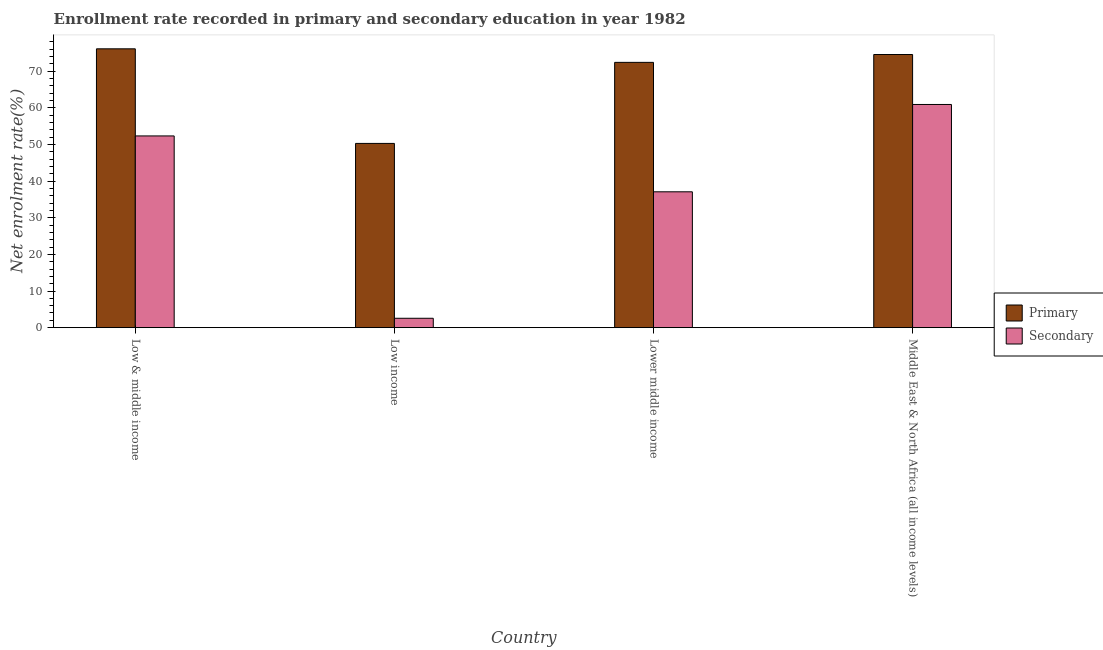How many different coloured bars are there?
Ensure brevity in your answer.  2. How many groups of bars are there?
Provide a short and direct response. 4. Are the number of bars per tick equal to the number of legend labels?
Offer a terse response. Yes. How many bars are there on the 3rd tick from the right?
Make the answer very short. 2. In how many cases, is the number of bars for a given country not equal to the number of legend labels?
Ensure brevity in your answer.  0. What is the enrollment rate in secondary education in Middle East & North Africa (all income levels)?
Make the answer very short. 60.88. Across all countries, what is the maximum enrollment rate in secondary education?
Give a very brief answer. 60.88. Across all countries, what is the minimum enrollment rate in secondary education?
Provide a succinct answer. 2.56. In which country was the enrollment rate in secondary education minimum?
Make the answer very short. Low income. What is the total enrollment rate in secondary education in the graph?
Your answer should be compact. 152.8. What is the difference between the enrollment rate in primary education in Low income and that in Lower middle income?
Keep it short and to the point. -22.11. What is the difference between the enrollment rate in secondary education in Low income and the enrollment rate in primary education in Middle East & North Africa (all income levels)?
Ensure brevity in your answer.  -71.95. What is the average enrollment rate in secondary education per country?
Give a very brief answer. 38.2. What is the difference between the enrollment rate in secondary education and enrollment rate in primary education in Low & middle income?
Keep it short and to the point. -23.76. In how many countries, is the enrollment rate in primary education greater than 2 %?
Give a very brief answer. 4. What is the ratio of the enrollment rate in primary education in Low & middle income to that in Low income?
Keep it short and to the point. 1.51. Is the enrollment rate in primary education in Low & middle income less than that in Middle East & North Africa (all income levels)?
Your answer should be compact. No. What is the difference between the highest and the second highest enrollment rate in secondary education?
Ensure brevity in your answer.  8.58. What is the difference between the highest and the lowest enrollment rate in primary education?
Your response must be concise. 25.8. What does the 1st bar from the left in Low income represents?
Make the answer very short. Primary. What does the 2nd bar from the right in Low income represents?
Ensure brevity in your answer.  Primary. How many bars are there?
Your answer should be compact. 8. Are the values on the major ticks of Y-axis written in scientific E-notation?
Give a very brief answer. No. How many legend labels are there?
Give a very brief answer. 2. What is the title of the graph?
Provide a succinct answer. Enrollment rate recorded in primary and secondary education in year 1982. Does "Borrowers" appear as one of the legend labels in the graph?
Make the answer very short. No. What is the label or title of the X-axis?
Ensure brevity in your answer.  Country. What is the label or title of the Y-axis?
Provide a short and direct response. Net enrolment rate(%). What is the Net enrolment rate(%) of Primary in Low & middle income?
Give a very brief answer. 76.06. What is the Net enrolment rate(%) of Secondary in Low & middle income?
Your answer should be compact. 52.3. What is the Net enrolment rate(%) in Primary in Low income?
Provide a short and direct response. 50.26. What is the Net enrolment rate(%) in Secondary in Low income?
Your response must be concise. 2.56. What is the Net enrolment rate(%) in Primary in Lower middle income?
Your answer should be very brief. 72.37. What is the Net enrolment rate(%) of Secondary in Lower middle income?
Offer a very short reply. 37.06. What is the Net enrolment rate(%) in Primary in Middle East & North Africa (all income levels)?
Keep it short and to the point. 74.51. What is the Net enrolment rate(%) in Secondary in Middle East & North Africa (all income levels)?
Offer a terse response. 60.88. Across all countries, what is the maximum Net enrolment rate(%) of Primary?
Your answer should be very brief. 76.06. Across all countries, what is the maximum Net enrolment rate(%) of Secondary?
Offer a very short reply. 60.88. Across all countries, what is the minimum Net enrolment rate(%) in Primary?
Offer a terse response. 50.26. Across all countries, what is the minimum Net enrolment rate(%) in Secondary?
Provide a short and direct response. 2.56. What is the total Net enrolment rate(%) in Primary in the graph?
Give a very brief answer. 273.2. What is the total Net enrolment rate(%) of Secondary in the graph?
Your response must be concise. 152.8. What is the difference between the Net enrolment rate(%) of Primary in Low & middle income and that in Low income?
Your answer should be very brief. 25.8. What is the difference between the Net enrolment rate(%) of Secondary in Low & middle income and that in Low income?
Offer a terse response. 49.74. What is the difference between the Net enrolment rate(%) in Primary in Low & middle income and that in Lower middle income?
Provide a succinct answer. 3.7. What is the difference between the Net enrolment rate(%) of Secondary in Low & middle income and that in Lower middle income?
Give a very brief answer. 15.24. What is the difference between the Net enrolment rate(%) of Primary in Low & middle income and that in Middle East & North Africa (all income levels)?
Keep it short and to the point. 1.55. What is the difference between the Net enrolment rate(%) in Secondary in Low & middle income and that in Middle East & North Africa (all income levels)?
Your answer should be compact. -8.58. What is the difference between the Net enrolment rate(%) of Primary in Low income and that in Lower middle income?
Provide a succinct answer. -22.11. What is the difference between the Net enrolment rate(%) in Secondary in Low income and that in Lower middle income?
Provide a succinct answer. -34.5. What is the difference between the Net enrolment rate(%) of Primary in Low income and that in Middle East & North Africa (all income levels)?
Offer a terse response. -24.25. What is the difference between the Net enrolment rate(%) of Secondary in Low income and that in Middle East & North Africa (all income levels)?
Your answer should be compact. -58.32. What is the difference between the Net enrolment rate(%) in Primary in Lower middle income and that in Middle East & North Africa (all income levels)?
Give a very brief answer. -2.14. What is the difference between the Net enrolment rate(%) of Secondary in Lower middle income and that in Middle East & North Africa (all income levels)?
Provide a short and direct response. -23.82. What is the difference between the Net enrolment rate(%) in Primary in Low & middle income and the Net enrolment rate(%) in Secondary in Low income?
Provide a short and direct response. 73.5. What is the difference between the Net enrolment rate(%) in Primary in Low & middle income and the Net enrolment rate(%) in Secondary in Lower middle income?
Provide a short and direct response. 39.01. What is the difference between the Net enrolment rate(%) in Primary in Low & middle income and the Net enrolment rate(%) in Secondary in Middle East & North Africa (all income levels)?
Your answer should be very brief. 15.18. What is the difference between the Net enrolment rate(%) in Primary in Low income and the Net enrolment rate(%) in Secondary in Lower middle income?
Offer a very short reply. 13.2. What is the difference between the Net enrolment rate(%) of Primary in Low income and the Net enrolment rate(%) of Secondary in Middle East & North Africa (all income levels)?
Give a very brief answer. -10.62. What is the difference between the Net enrolment rate(%) in Primary in Lower middle income and the Net enrolment rate(%) in Secondary in Middle East & North Africa (all income levels)?
Provide a succinct answer. 11.49. What is the average Net enrolment rate(%) of Primary per country?
Provide a succinct answer. 68.3. What is the average Net enrolment rate(%) in Secondary per country?
Give a very brief answer. 38.2. What is the difference between the Net enrolment rate(%) in Primary and Net enrolment rate(%) in Secondary in Low & middle income?
Keep it short and to the point. 23.76. What is the difference between the Net enrolment rate(%) of Primary and Net enrolment rate(%) of Secondary in Low income?
Ensure brevity in your answer.  47.7. What is the difference between the Net enrolment rate(%) of Primary and Net enrolment rate(%) of Secondary in Lower middle income?
Offer a very short reply. 35.31. What is the difference between the Net enrolment rate(%) of Primary and Net enrolment rate(%) of Secondary in Middle East & North Africa (all income levels)?
Offer a terse response. 13.63. What is the ratio of the Net enrolment rate(%) of Primary in Low & middle income to that in Low income?
Ensure brevity in your answer.  1.51. What is the ratio of the Net enrolment rate(%) in Secondary in Low & middle income to that in Low income?
Keep it short and to the point. 20.42. What is the ratio of the Net enrolment rate(%) in Primary in Low & middle income to that in Lower middle income?
Provide a short and direct response. 1.05. What is the ratio of the Net enrolment rate(%) of Secondary in Low & middle income to that in Lower middle income?
Give a very brief answer. 1.41. What is the ratio of the Net enrolment rate(%) of Primary in Low & middle income to that in Middle East & North Africa (all income levels)?
Ensure brevity in your answer.  1.02. What is the ratio of the Net enrolment rate(%) in Secondary in Low & middle income to that in Middle East & North Africa (all income levels)?
Provide a short and direct response. 0.86. What is the ratio of the Net enrolment rate(%) of Primary in Low income to that in Lower middle income?
Your answer should be very brief. 0.69. What is the ratio of the Net enrolment rate(%) of Secondary in Low income to that in Lower middle income?
Ensure brevity in your answer.  0.07. What is the ratio of the Net enrolment rate(%) in Primary in Low income to that in Middle East & North Africa (all income levels)?
Your response must be concise. 0.67. What is the ratio of the Net enrolment rate(%) in Secondary in Low income to that in Middle East & North Africa (all income levels)?
Give a very brief answer. 0.04. What is the ratio of the Net enrolment rate(%) in Primary in Lower middle income to that in Middle East & North Africa (all income levels)?
Offer a terse response. 0.97. What is the ratio of the Net enrolment rate(%) in Secondary in Lower middle income to that in Middle East & North Africa (all income levels)?
Give a very brief answer. 0.61. What is the difference between the highest and the second highest Net enrolment rate(%) in Primary?
Your response must be concise. 1.55. What is the difference between the highest and the second highest Net enrolment rate(%) of Secondary?
Offer a very short reply. 8.58. What is the difference between the highest and the lowest Net enrolment rate(%) of Primary?
Your answer should be very brief. 25.8. What is the difference between the highest and the lowest Net enrolment rate(%) of Secondary?
Provide a succinct answer. 58.32. 